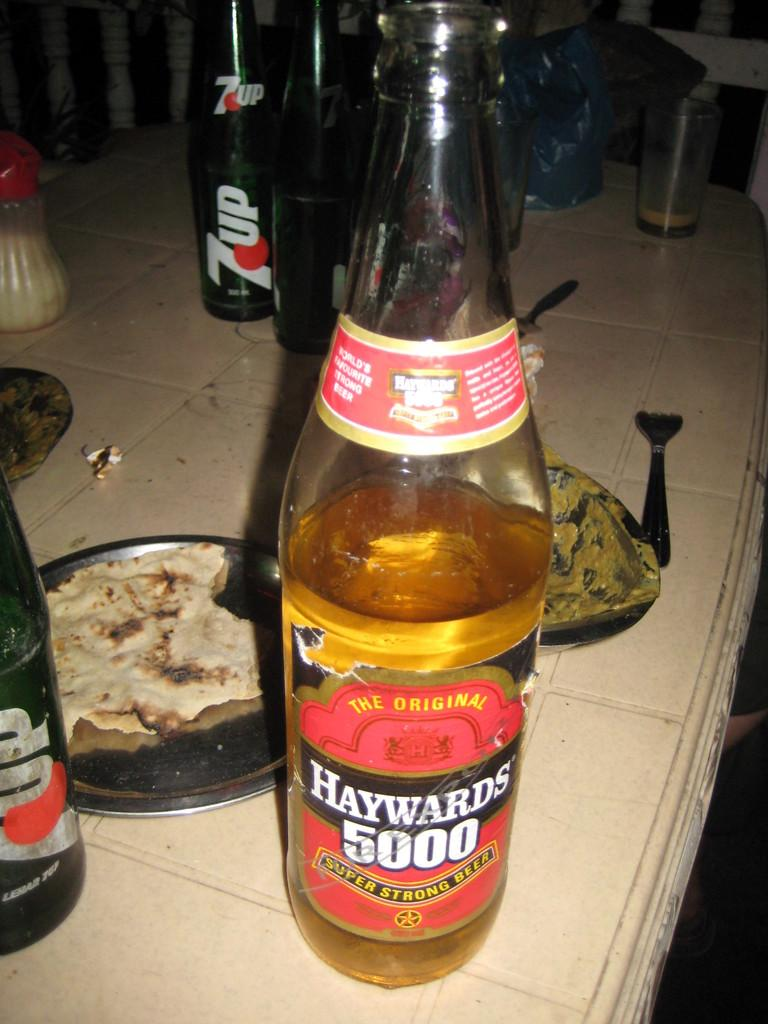<image>
Write a terse but informative summary of the picture. A bottle of Haywards 5000 super stron gbeer 